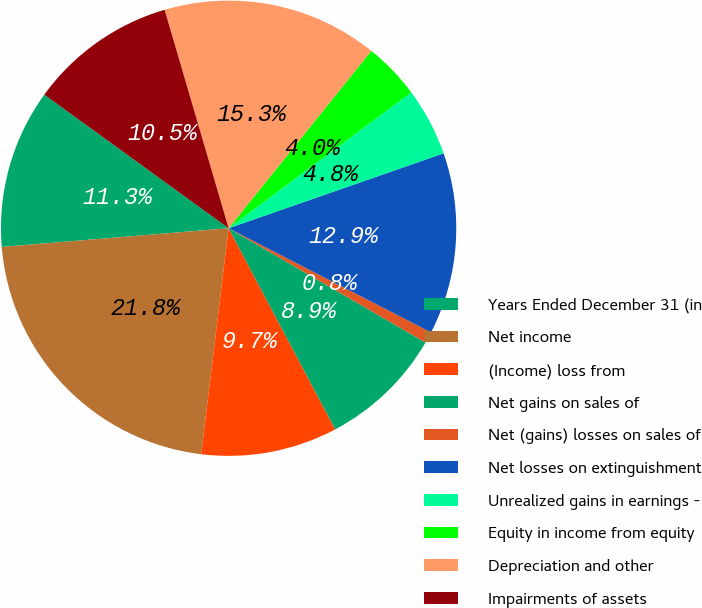Convert chart to OTSL. <chart><loc_0><loc_0><loc_500><loc_500><pie_chart><fcel>Years Ended December 31 (in<fcel>Net income<fcel>(Income) loss from<fcel>Net gains on sales of<fcel>Net (gains) losses on sales of<fcel>Net losses on extinguishment<fcel>Unrealized gains in earnings -<fcel>Equity in income from equity<fcel>Depreciation and other<fcel>Impairments of assets<nl><fcel>11.29%<fcel>21.77%<fcel>9.68%<fcel>8.87%<fcel>0.81%<fcel>12.9%<fcel>4.84%<fcel>4.04%<fcel>15.32%<fcel>10.48%<nl></chart> 